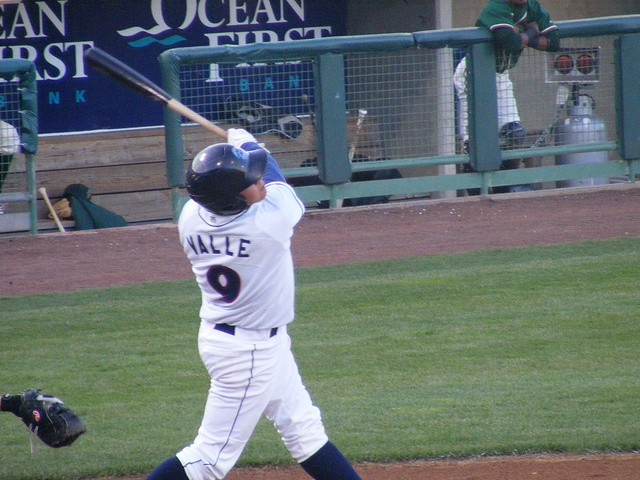Describe the objects in this image and their specific colors. I can see people in salmon, lavender, black, and navy tones, bench in salmon, gray, blue, and navy tones, people in salmon, teal, black, gray, and navy tones, baseball glove in salmon, black, gray, navy, and darkblue tones, and baseball bat in salmon, navy, black, and gray tones in this image. 